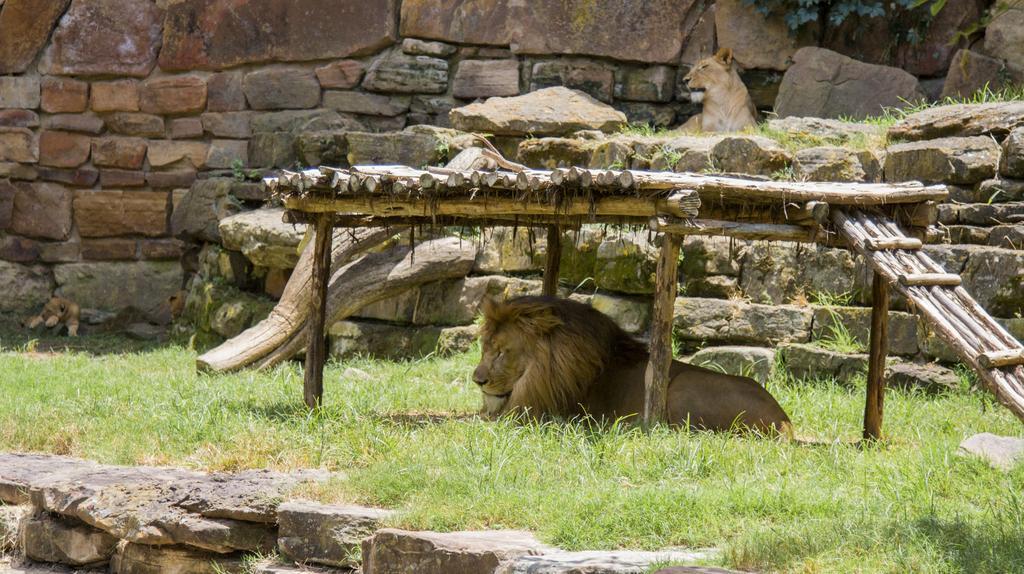In one or two sentences, can you explain what this image depicts? In this image there is a lion as we can see at bottom of this image and there is a some grass in middle of this image and there is a wall in the background. 